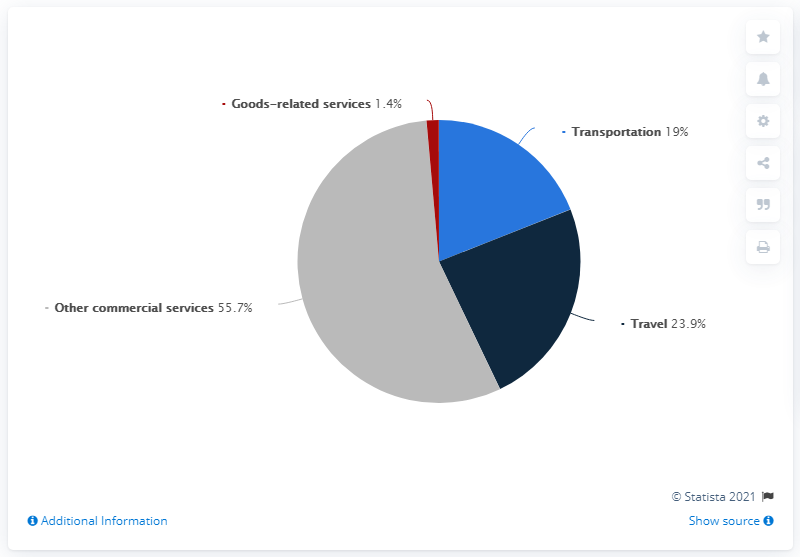Outline some significant characteristics in this image. The result of subtracting transportation from travel and then dividing goods-related services is 3.5. The second largest colored segment is navy blue. 